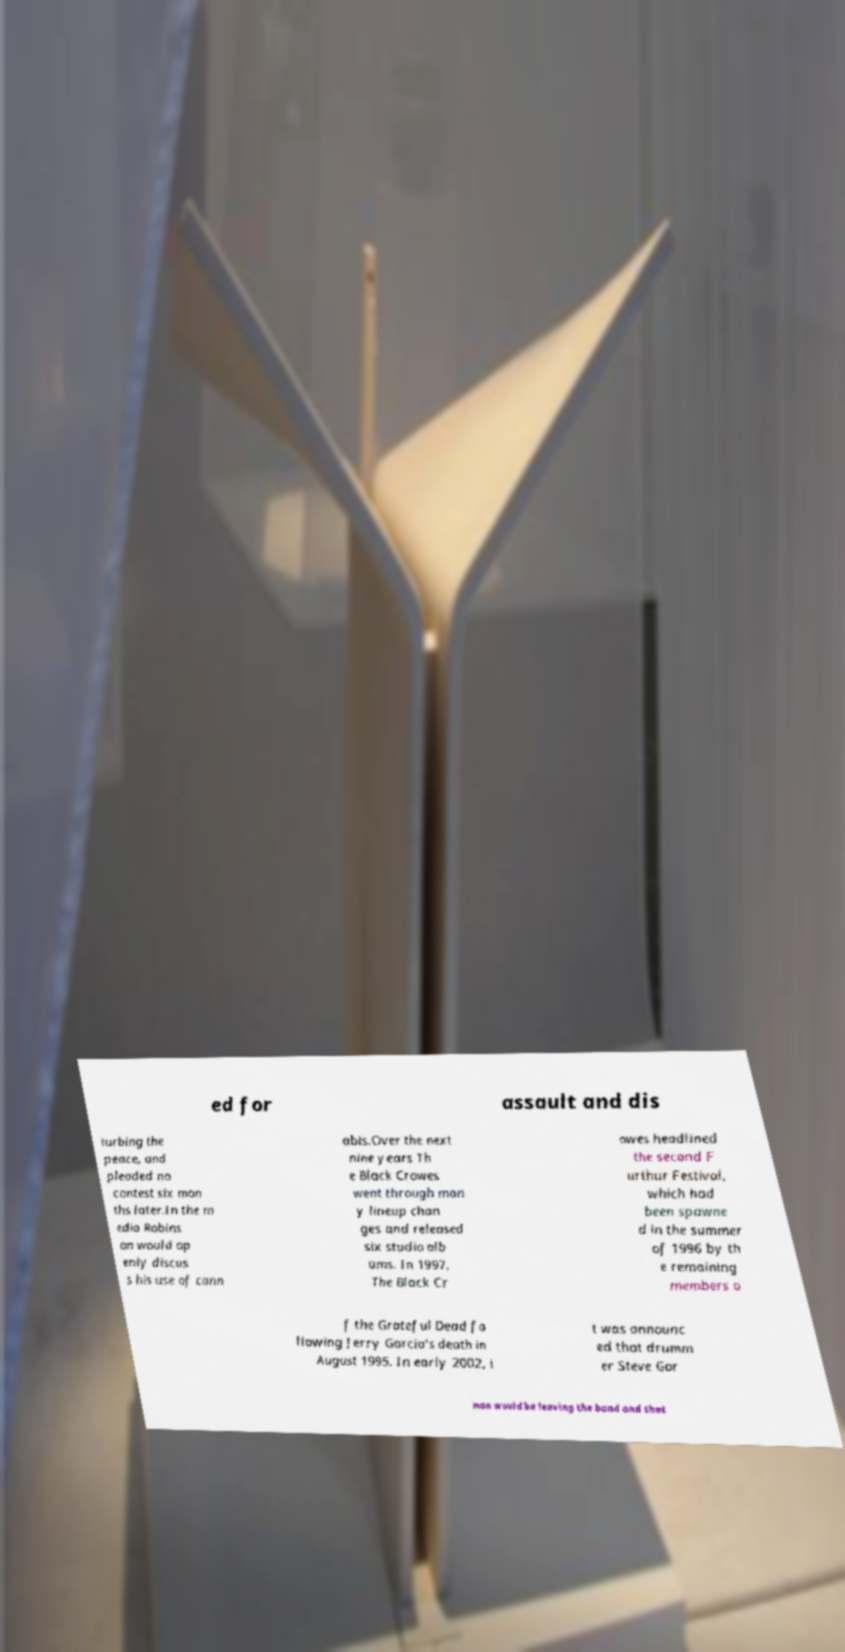Please read and relay the text visible in this image. What does it say? ed for assault and dis turbing the peace, and pleaded no contest six mon ths later.In the m edia Robins on would op enly discus s his use of cann abis.Over the next nine years Th e Black Crowes went through man y lineup chan ges and released six studio alb ums. In 1997, The Black Cr owes headlined the second F urthur Festival, which had been spawne d in the summer of 1996 by th e remaining members o f the Grateful Dead fo llowing Jerry Garcia's death in August 1995. In early 2002, i t was announc ed that drumm er Steve Gor man would be leaving the band and that 